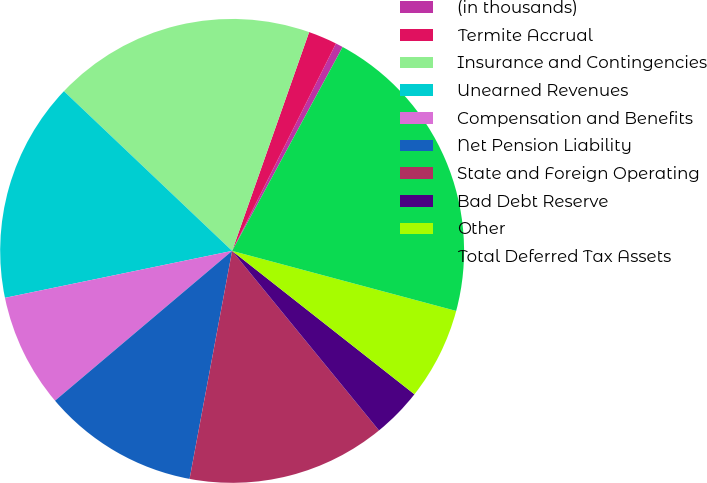Convert chart. <chart><loc_0><loc_0><loc_500><loc_500><pie_chart><fcel>(in thousands)<fcel>Termite Accrual<fcel>Insurance and Contingencies<fcel>Unearned Revenues<fcel>Compensation and Benefits<fcel>Net Pension Liability<fcel>State and Foreign Operating<fcel>Bad Debt Reserve<fcel>Other<fcel>Total Deferred Tax Assets<nl><fcel>0.52%<fcel>2.0%<fcel>18.3%<fcel>15.33%<fcel>7.93%<fcel>10.89%<fcel>13.85%<fcel>3.48%<fcel>6.44%<fcel>21.26%<nl></chart> 